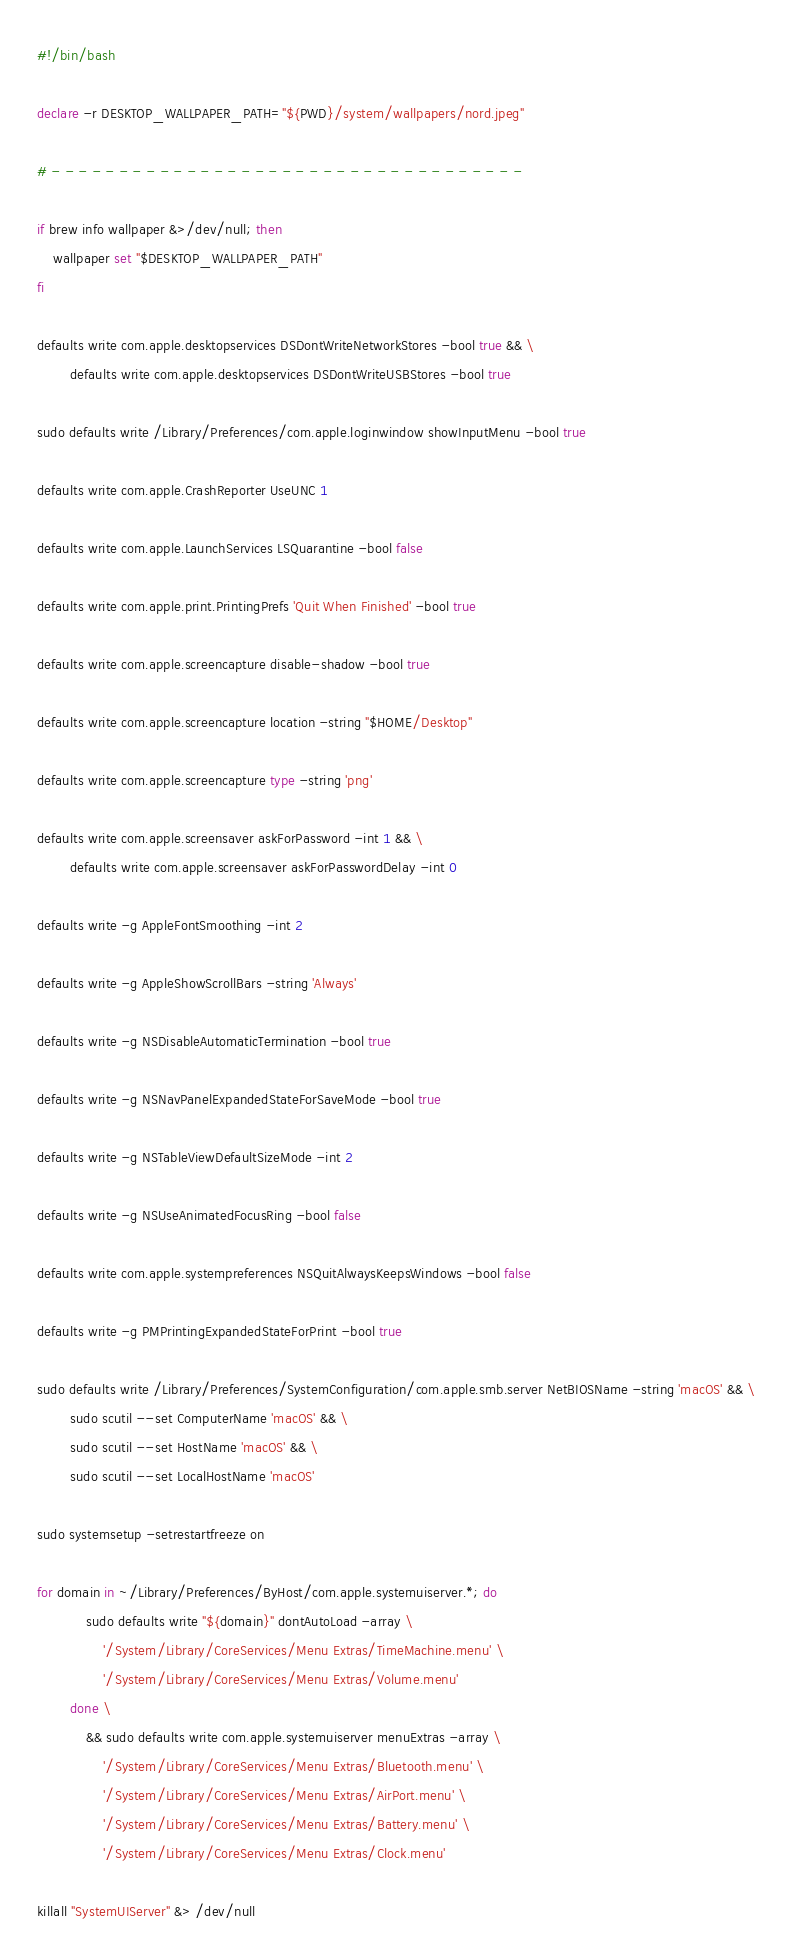Convert code to text. <code><loc_0><loc_0><loc_500><loc_500><_Bash_>#!/bin/bash

declare -r DESKTOP_WALLPAPER_PATH="${PWD}/system/wallpapers/nord.jpeg"

# - - - - - - - - - - - - - - - - - - - - - - - - - - - - - - - - - - -

if brew info wallpaper &>/dev/null; then
	wallpaper set "$DESKTOP_WALLPAPER_PATH"
fi

defaults write com.apple.desktopservices DSDontWriteNetworkStores -bool true && \
		defaults write com.apple.desktopservices DSDontWriteUSBStores -bool true

sudo defaults write /Library/Preferences/com.apple.loginwindow showInputMenu -bool true

defaults write com.apple.CrashReporter UseUNC 1

defaults write com.apple.LaunchServices LSQuarantine -bool false

defaults write com.apple.print.PrintingPrefs 'Quit When Finished' -bool true

defaults write com.apple.screencapture disable-shadow -bool true

defaults write com.apple.screencapture location -string "$HOME/Desktop"

defaults write com.apple.screencapture type -string 'png'

defaults write com.apple.screensaver askForPassword -int 1 && \
		defaults write com.apple.screensaver askForPasswordDelay -int 0

defaults write -g AppleFontSmoothing -int 2

defaults write -g AppleShowScrollBars -string 'Always'

defaults write -g NSDisableAutomaticTermination -bool true

defaults write -g NSNavPanelExpandedStateForSaveMode -bool true

defaults write -g NSTableViewDefaultSizeMode -int 2

defaults write -g NSUseAnimatedFocusRing -bool false

defaults write com.apple.systempreferences NSQuitAlwaysKeepsWindows -bool false

defaults write -g PMPrintingExpandedStateForPrint -bool true

sudo defaults write /Library/Preferences/SystemConfiguration/com.apple.smb.server NetBIOSName -string 'macOS' && \
		sudo scutil --set ComputerName 'macOS' && \
		sudo scutil --set HostName 'macOS' && \
		sudo scutil --set LocalHostName 'macOS'

sudo systemsetup -setrestartfreeze on

for domain in ~/Library/Preferences/ByHost/com.apple.systemuiserver.*; do
            sudo defaults write "${domain}" dontAutoLoad -array \
                '/System/Library/CoreServices/Menu Extras/TimeMachine.menu' \
                '/System/Library/CoreServices/Menu Extras/Volume.menu'
		done \
            && sudo defaults write com.apple.systemuiserver menuExtras -array \
                '/System/Library/CoreServices/Menu Extras/Bluetooth.menu' \
                '/System/Library/CoreServices/Menu Extras/AirPort.menu' \
                '/System/Library/CoreServices/Menu Extras/Battery.menu' \
                '/System/Library/CoreServices/Menu Extras/Clock.menu'

killall "SystemUIServer" &> /dev/null
</code> 